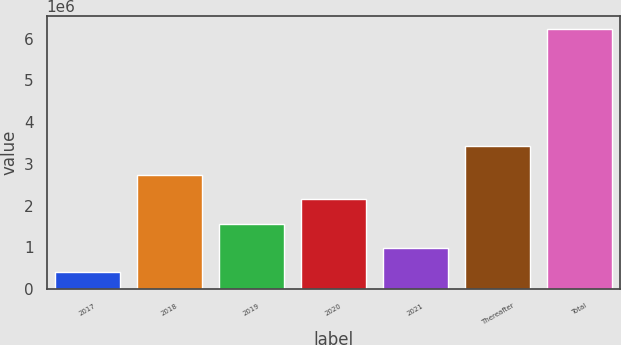Convert chart. <chart><loc_0><loc_0><loc_500><loc_500><bar_chart><fcel>2017<fcel>2018<fcel>2019<fcel>2020<fcel>2021<fcel>Thereafter<fcel>Total<nl><fcel>401595<fcel>2.73415e+06<fcel>1.56787e+06<fcel>2.15101e+06<fcel>984734<fcel>3.43e+06<fcel>6.23299e+06<nl></chart> 